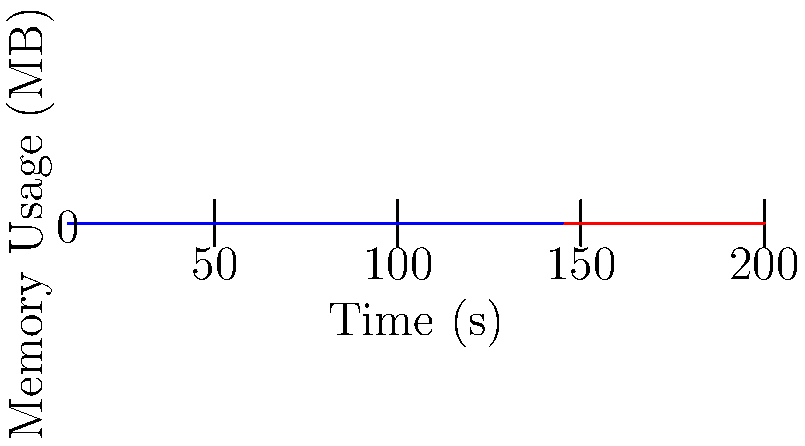Based on the graph showing memory usage patterns for a large-scale simulation in Java and C++, what can be inferred about the memory management efficiency of C++ compared to Java for this high-performance computing task? To analyze the memory usage patterns and efficiency of C++ compared to Java for this high-performance computing task, let's follow these steps:

1. Observe the general trend:
   - The red line represents Java's memory usage.
   - The blue line represents C++'s memory usage.
   - Both lines show an increasing trend over time.

2. Compare the slopes:
   - Java's line has a steeper slope.
   - C++'s line has a more gradual slope.

3. Analyze the memory usage at different time points:
   - At the start (t = 0s), Java uses about 20MB, while C++ uses about 10MB.
   - At the end (t = 9s), Java uses about 200MB, while C++ uses about 145MB.

4. Calculate the rate of memory increase:
   - Java: (200MB - 20MB) / 9s ≈ 20MB/s
   - C++: (145MB - 10MB) / 9s ≈ 15MB/s

5. Consider the implications:
   - C++ consistently uses less memory throughout the simulation.
   - C++'s memory usage increases at a slower rate.
   - This suggests that C++ has more efficient memory management for this task.

6. Relate to high-performance computing:
   - Lower memory usage in C++ can lead to better performance in memory-constrained environments.
   - More efficient memory management can result in faster execution times and better scalability.

Based on this analysis, we can infer that C++ demonstrates more efficient memory management compared to Java for this high-performance computing task, as evidenced by its lower overall memory usage and slower rate of memory consumption.
Answer: C++ shows more efficient memory management with lower usage and slower growth rate. 